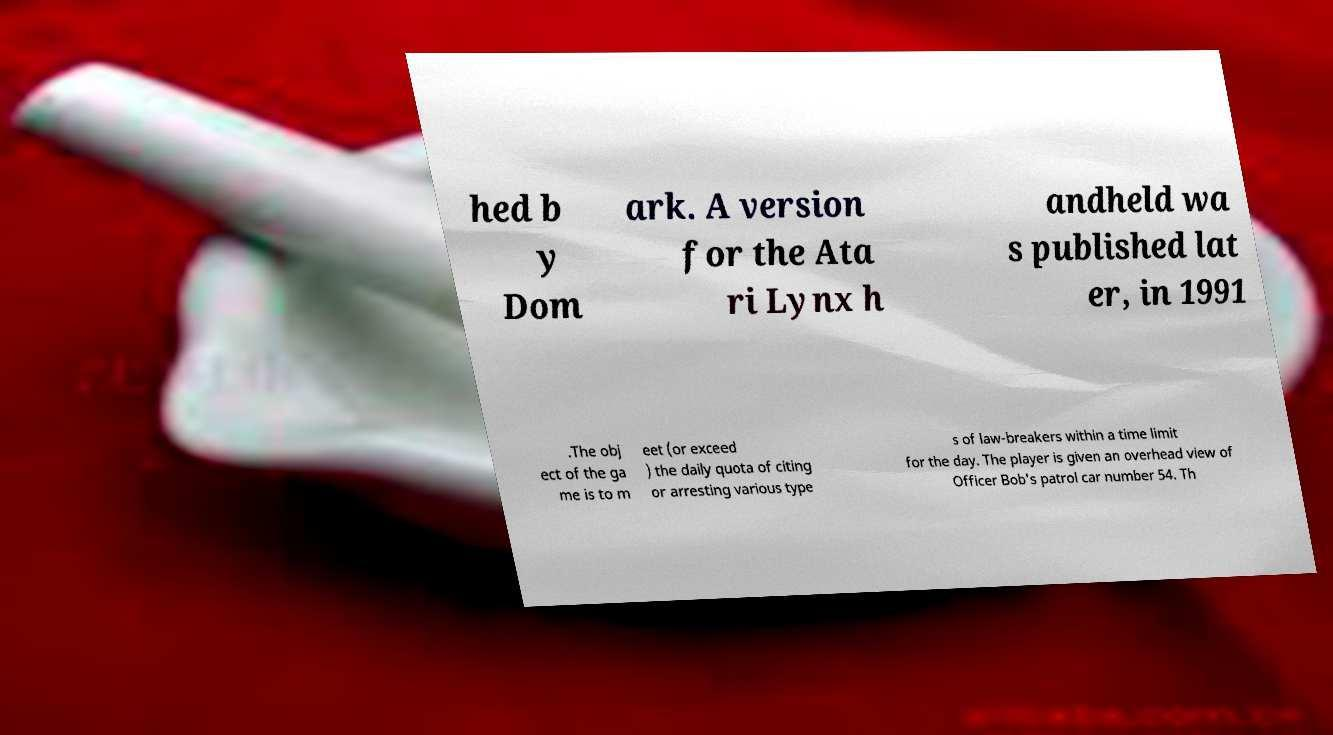What messages or text are displayed in this image? I need them in a readable, typed format. hed b y Dom ark. A version for the Ata ri Lynx h andheld wa s published lat er, in 1991 .The obj ect of the ga me is to m eet (or exceed ) the daily quota of citing or arresting various type s of law-breakers within a time limit for the day. The player is given an overhead view of Officer Bob's patrol car number 54. Th 